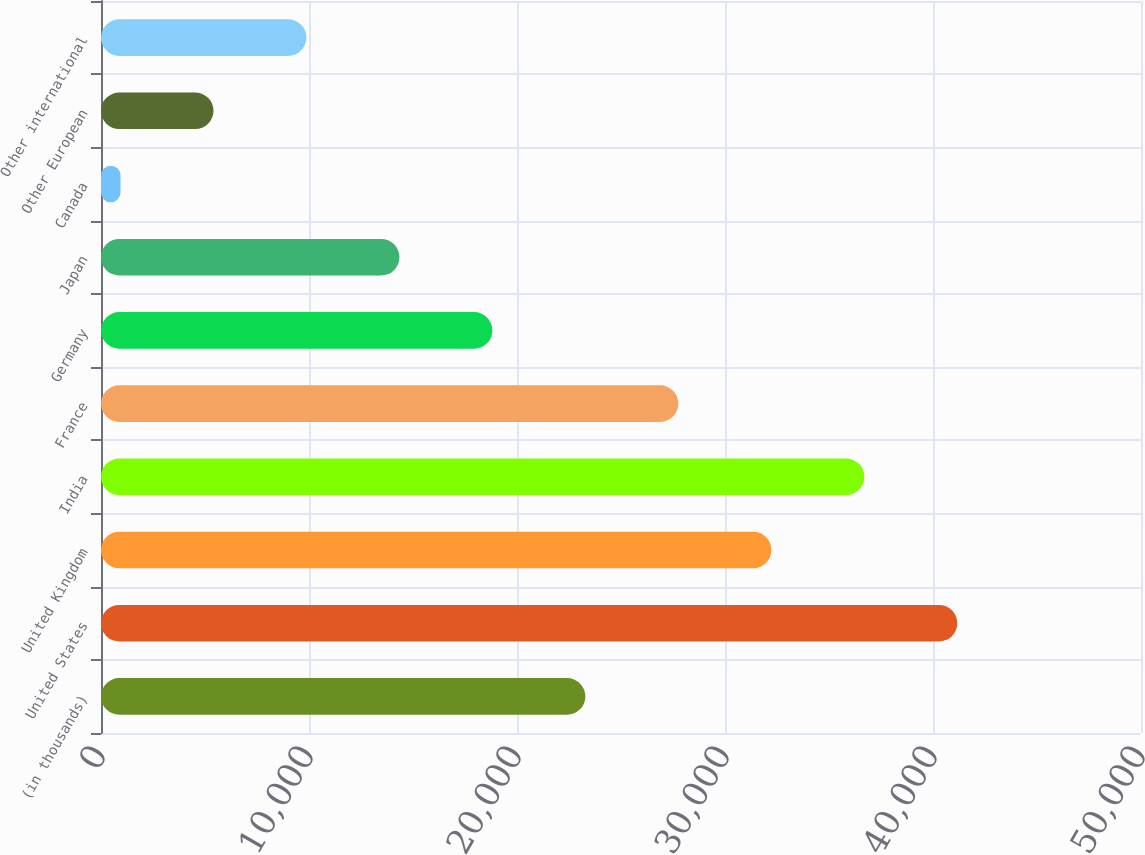Convert chart to OTSL. <chart><loc_0><loc_0><loc_500><loc_500><bar_chart><fcel>(in thousands)<fcel>United States<fcel>United Kingdom<fcel>India<fcel>France<fcel>Germany<fcel>Japan<fcel>Canada<fcel>Other European<fcel>Other international<nl><fcel>23288<fcel>41168<fcel>32228<fcel>36698<fcel>27758<fcel>18818<fcel>14348<fcel>938<fcel>5408<fcel>9878<nl></chart> 